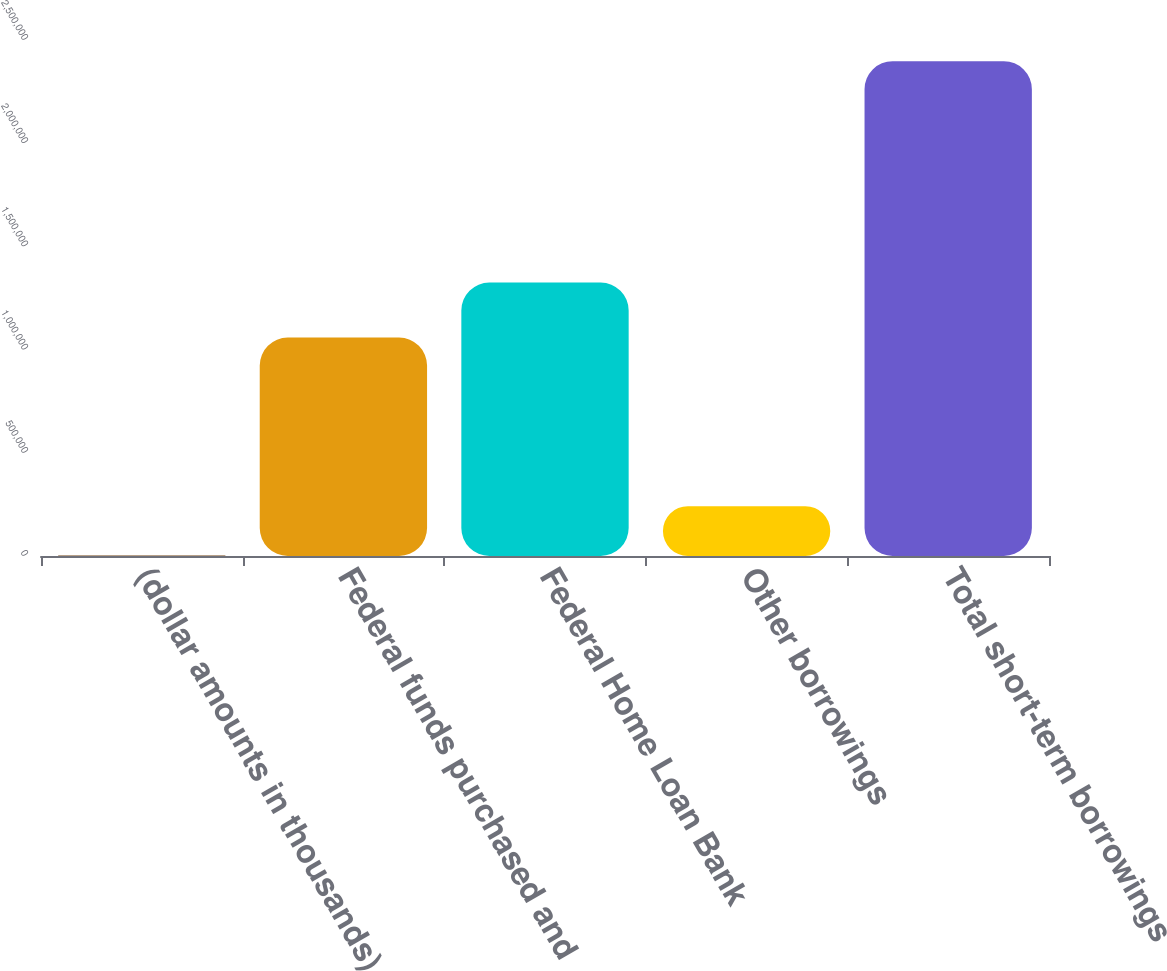Convert chart. <chart><loc_0><loc_0><loc_500><loc_500><bar_chart><fcel>(dollar amounts in thousands)<fcel>Federal funds purchased and<fcel>Federal Home Loan Bank<fcel>Other borrowings<fcel>Total short-term borrowings<nl><fcel>2014<fcel>1.0581e+06<fcel>1.325e+06<fcel>241523<fcel>2.3971e+06<nl></chart> 